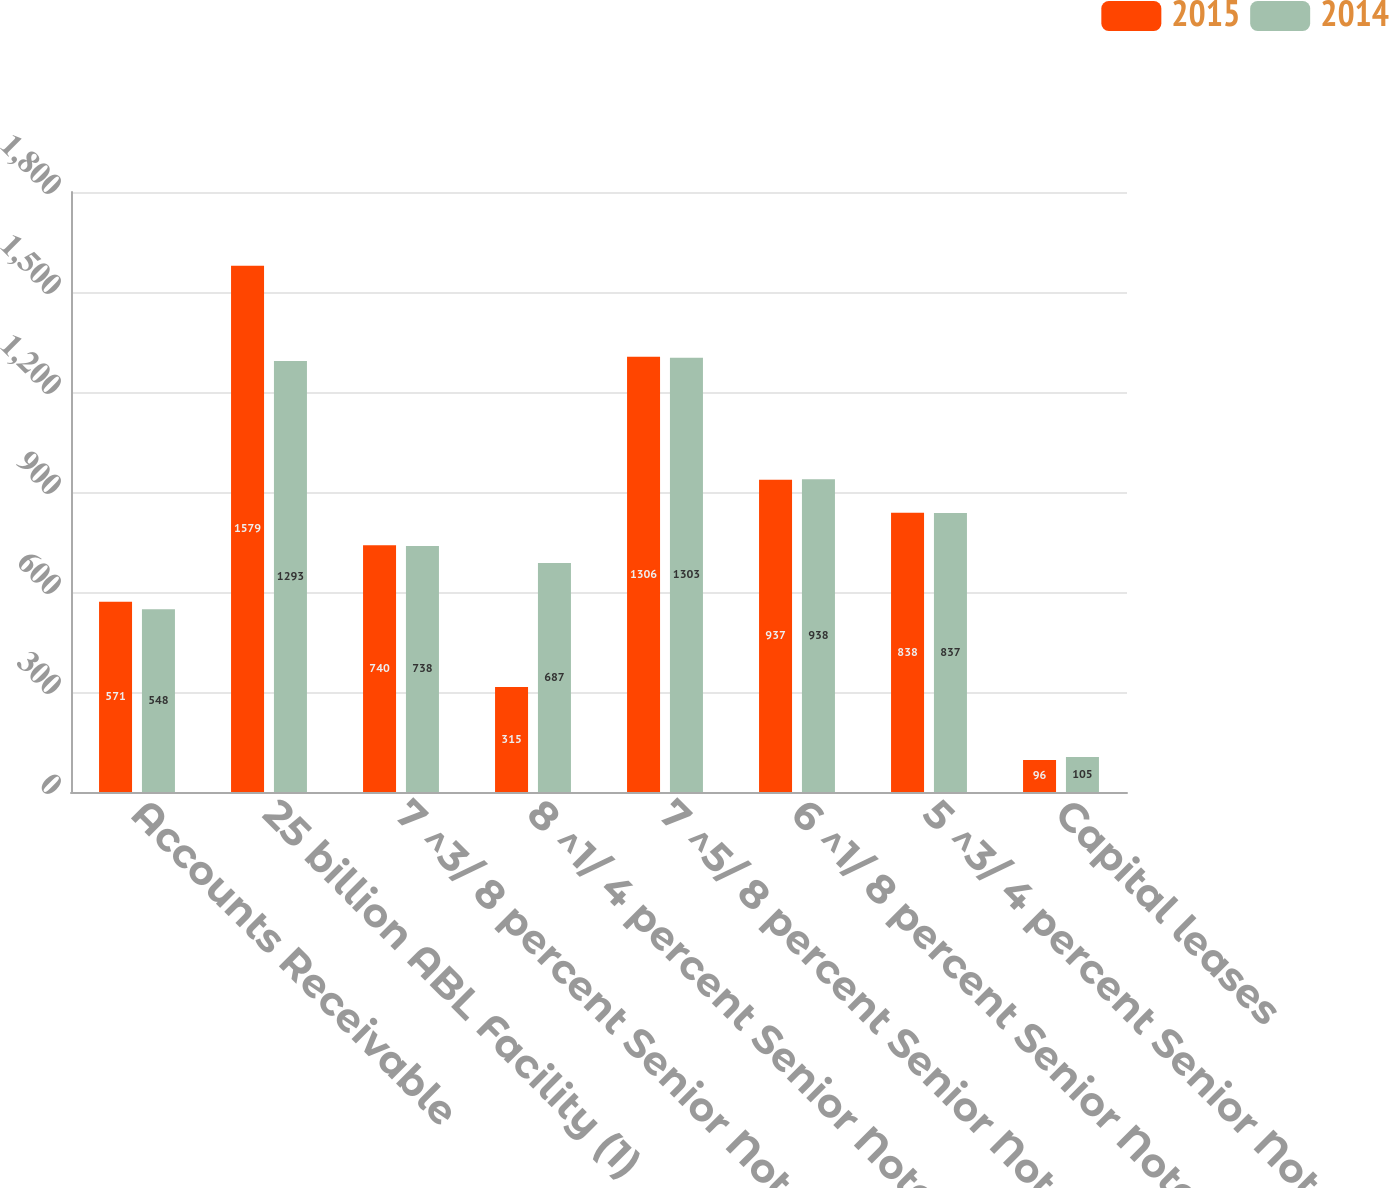<chart> <loc_0><loc_0><loc_500><loc_500><stacked_bar_chart><ecel><fcel>Accounts Receivable<fcel>25 billion ABL Facility (1)<fcel>7 ^3/ 8 percent Senior Notes<fcel>8 ^1/ 4 percent Senior Notes<fcel>7 ^5/ 8 percent Senior Notes<fcel>6 ^1/ 8 percent Senior Notes<fcel>5 ^3/ 4 percent Senior Notes<fcel>Capital leases<nl><fcel>2015<fcel>571<fcel>1579<fcel>740<fcel>315<fcel>1306<fcel>937<fcel>838<fcel>96<nl><fcel>2014<fcel>548<fcel>1293<fcel>738<fcel>687<fcel>1303<fcel>938<fcel>837<fcel>105<nl></chart> 